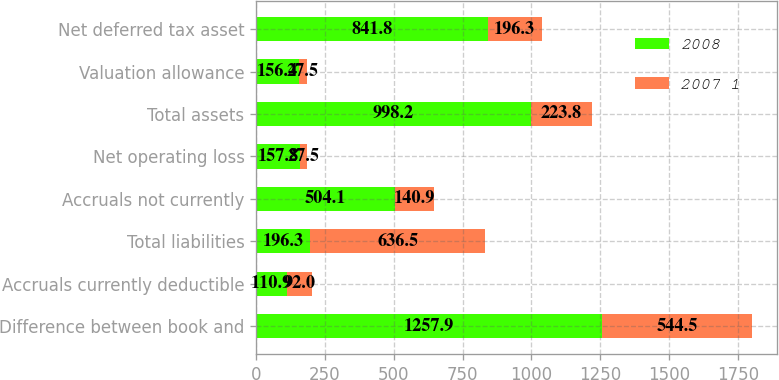Convert chart to OTSL. <chart><loc_0><loc_0><loc_500><loc_500><stacked_bar_chart><ecel><fcel>Difference between book and<fcel>Accruals currently deductible<fcel>Total liabilities<fcel>Accruals not currently<fcel>Net operating loss<fcel>Total assets<fcel>Valuation allowance<fcel>Net deferred tax asset<nl><fcel>2008<fcel>1257.9<fcel>110.9<fcel>196.3<fcel>504.1<fcel>157.8<fcel>998.2<fcel>156.4<fcel>841.8<nl><fcel>2007 1<fcel>544.5<fcel>92<fcel>636.5<fcel>140.9<fcel>27.5<fcel>223.8<fcel>27.5<fcel>196.3<nl></chart> 